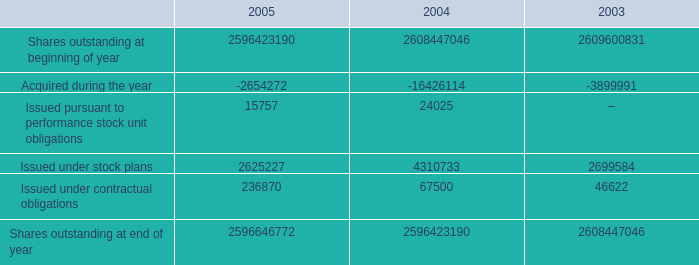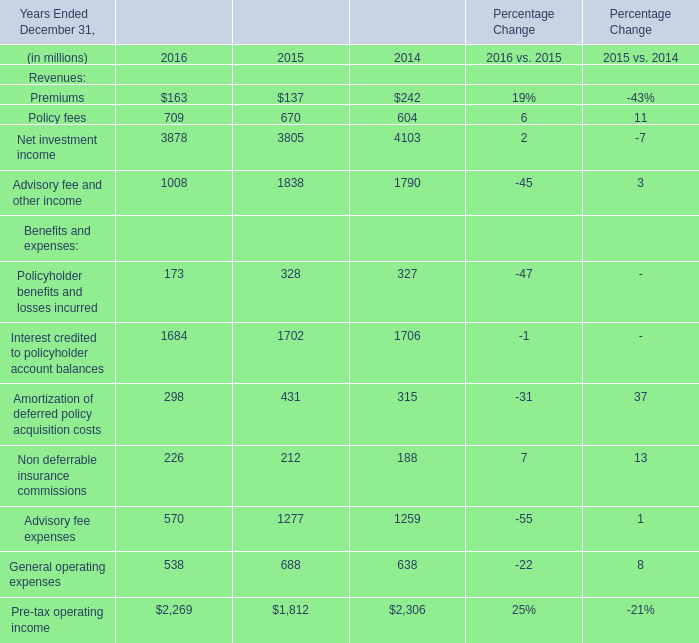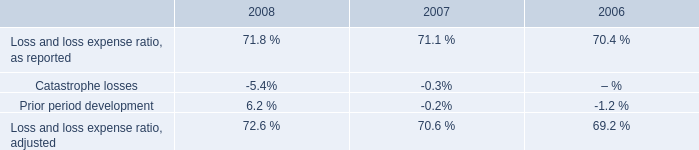in 2008 what was the ratio of the north american net favorable prior period development to the catastrophe losses 
Computations: (351 / 298)
Answer: 1.17785. 